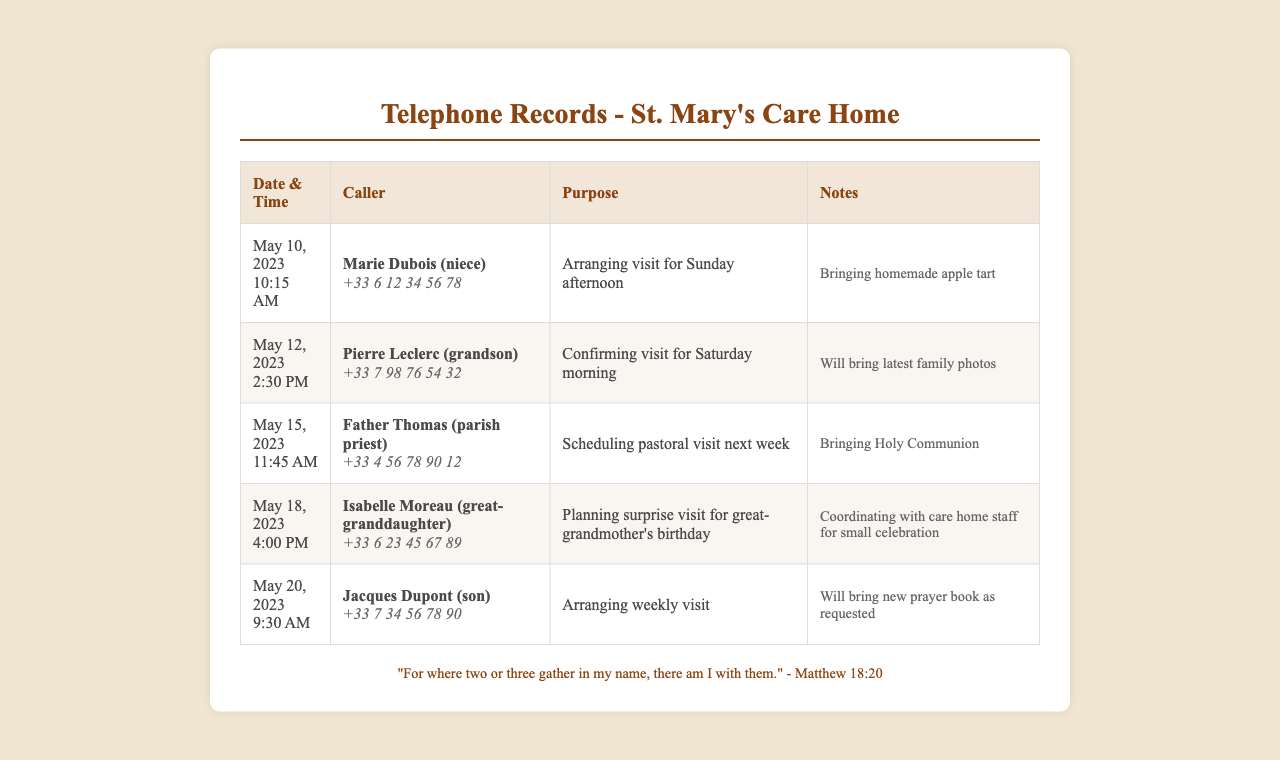What is the date of Marie Dubois's call? The date of Marie Dubois's call is mentioned as May 10, 2023.
Answer: May 10, 2023 Who is the caller for the visit scheduled for Saturday morning? The caller who confirmed the visit for Saturday morning is Pierre Leclerc.
Answer: Pierre Leclerc What time was Father Thomas's call? Father Thomas's call time is specified as 11:45 AM on May 15, 2023.
Answer: 11:45 AM What is Isabelle Moreau planning to celebrate? Isabelle Moreau is planning a surprise visit for her great-grandmother's birthday.
Answer: great-grandmother's birthday How many days before the visit did Jacques Dupont arrange his weekly visit? Jacques Dupont arranged his weekly visit on May 20, which is 7 days before May 27.
Answer: 7 days What type of food will Marie bring during her visit? Marie is bringing a homemade apple tart as noted in the call records.
Answer: homemade apple tart Which family member is bringing Holy Communion? The family member bringing Holy Communion is Father Thomas.
Answer: Father Thomas What is the purpose of the call made by Isabelle Moreau? The purpose of Isabelle Moreau's call is planning a surprise visit for a birthday celebration.
Answer: Planning surprise visit for great-grandmother's birthday Who is scheduled to bring family photos? The family member scheduled to bring family photos is Pierre Leclerc.
Answer: Pierre Leclerc 